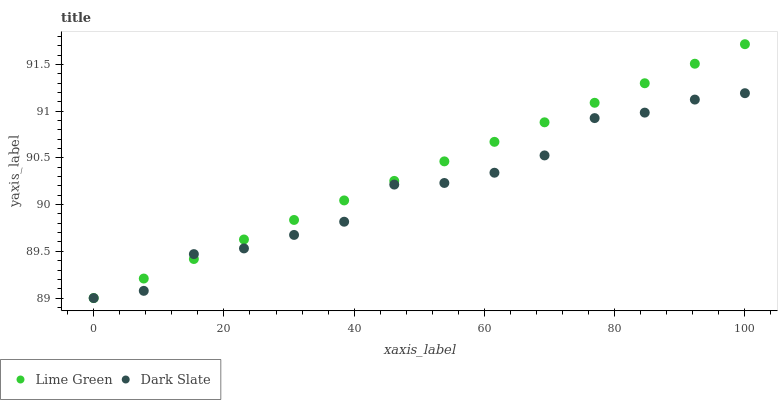Does Dark Slate have the minimum area under the curve?
Answer yes or no. Yes. Does Lime Green have the maximum area under the curve?
Answer yes or no. Yes. Does Lime Green have the minimum area under the curve?
Answer yes or no. No. Is Lime Green the smoothest?
Answer yes or no. Yes. Is Dark Slate the roughest?
Answer yes or no. Yes. Is Lime Green the roughest?
Answer yes or no. No. Does Dark Slate have the lowest value?
Answer yes or no. Yes. Does Lime Green have the highest value?
Answer yes or no. Yes. Does Lime Green intersect Dark Slate?
Answer yes or no. Yes. Is Lime Green less than Dark Slate?
Answer yes or no. No. Is Lime Green greater than Dark Slate?
Answer yes or no. No. 